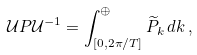<formula> <loc_0><loc_0><loc_500><loc_500>\mathcal { U } P \mathcal { U } ^ { - 1 } = \int ^ { \oplus } _ { [ 0 , 2 \pi / T ] } \widetilde { P } _ { k } \, d k \, ,</formula> 